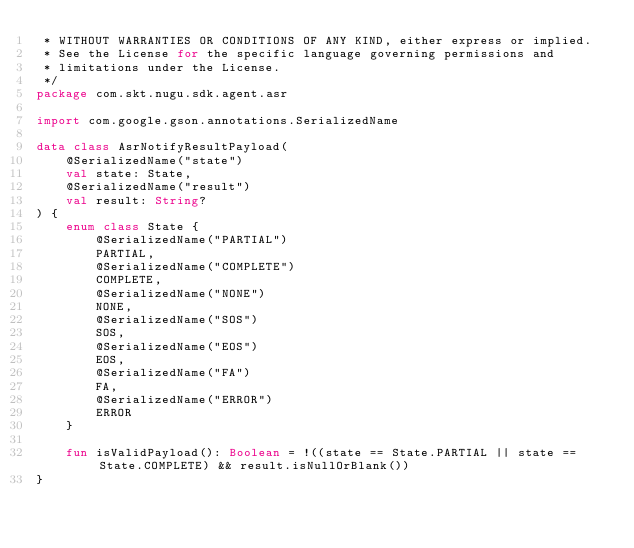<code> <loc_0><loc_0><loc_500><loc_500><_Kotlin_> * WITHOUT WARRANTIES OR CONDITIONS OF ANY KIND, either express or implied.
 * See the License for the specific language governing permissions and
 * limitations under the License.
 */
package com.skt.nugu.sdk.agent.asr

import com.google.gson.annotations.SerializedName

data class AsrNotifyResultPayload(
    @SerializedName("state")
    val state: State,
    @SerializedName("result")
    val result: String?
) {
    enum class State {
        @SerializedName("PARTIAL")
        PARTIAL,
        @SerializedName("COMPLETE")
        COMPLETE,
        @SerializedName("NONE")
        NONE,
        @SerializedName("SOS")
        SOS,
        @SerializedName("EOS")
        EOS,
        @SerializedName("FA")
        FA,
        @SerializedName("ERROR")
        ERROR
    }

    fun isValidPayload(): Boolean = !((state == State.PARTIAL || state == State.COMPLETE) && result.isNullOrBlank())
}</code> 